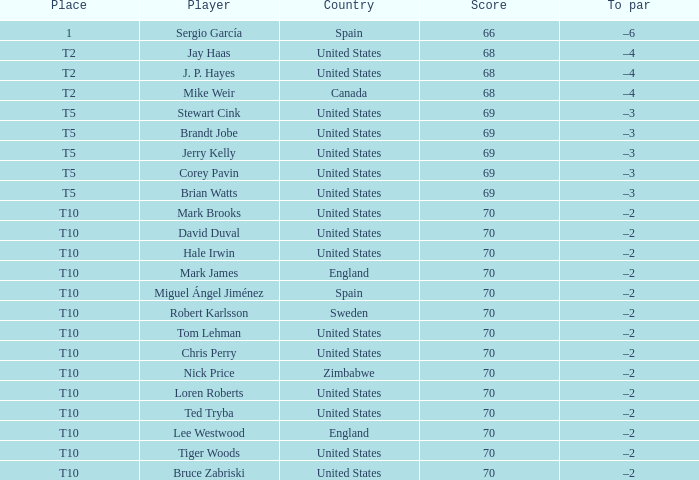Parse the table in full. {'header': ['Place', 'Player', 'Country', 'Score', 'To par'], 'rows': [['1', 'Sergio García', 'Spain', '66', '–6'], ['T2', 'Jay Haas', 'United States', '68', '–4'], ['T2', 'J. P. Hayes', 'United States', '68', '–4'], ['T2', 'Mike Weir', 'Canada', '68', '–4'], ['T5', 'Stewart Cink', 'United States', '69', '–3'], ['T5', 'Brandt Jobe', 'United States', '69', '–3'], ['T5', 'Jerry Kelly', 'United States', '69', '–3'], ['T5', 'Corey Pavin', 'United States', '69', '–3'], ['T5', 'Brian Watts', 'United States', '69', '–3'], ['T10', 'Mark Brooks', 'United States', '70', '–2'], ['T10', 'David Duval', 'United States', '70', '–2'], ['T10', 'Hale Irwin', 'United States', '70', '–2'], ['T10', 'Mark James', 'England', '70', '–2'], ['T10', 'Miguel Ángel Jiménez', 'Spain', '70', '–2'], ['T10', 'Robert Karlsson', 'Sweden', '70', '–2'], ['T10', 'Tom Lehman', 'United States', '70', '–2'], ['T10', 'Chris Perry', 'United States', '70', '–2'], ['T10', 'Nick Price', 'Zimbabwe', '70', '–2'], ['T10', 'Loren Roberts', 'United States', '70', '–2'], ['T10', 'Ted Tryba', 'United States', '70', '–2'], ['T10', 'Lee Westwood', 'England', '70', '–2'], ['T10', 'Tiger Woods', 'United States', '70', '–2'], ['T10', 'Bruce Zabriski', 'United States', '70', '–2']]} What was the To par of the golfer that placed t5? –3, –3, –3, –3, –3. 